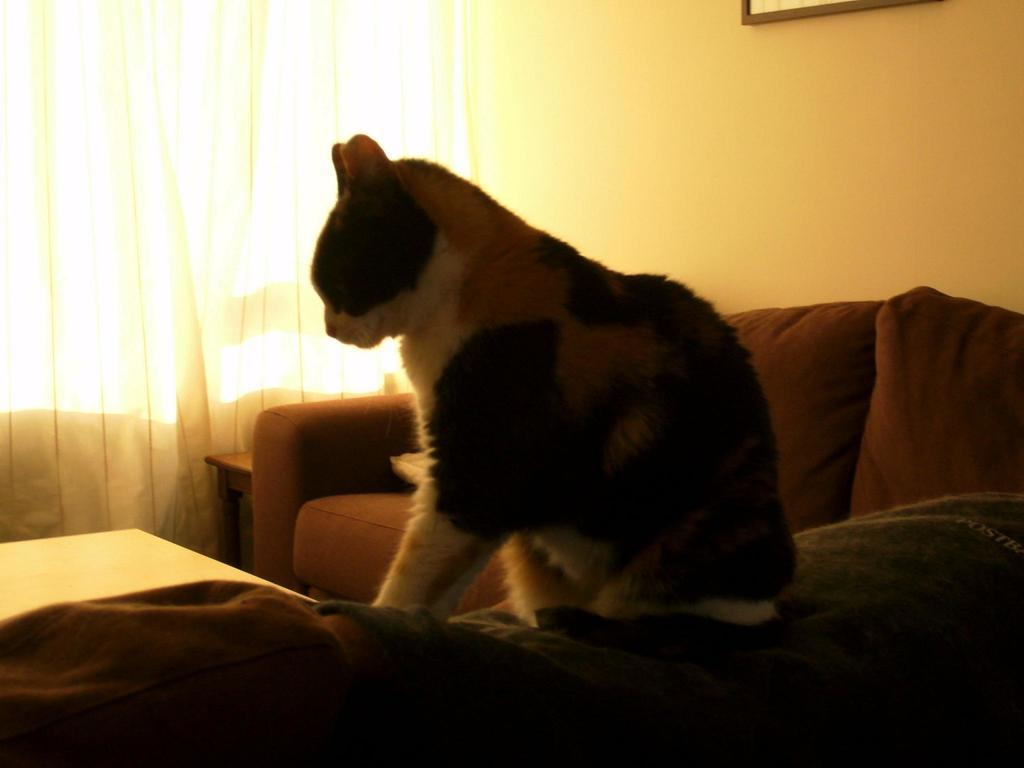What animal can be seen in the image? There is a cat in the image. Where is the cat located? The cat is sitting on a sofa. What is hanging on the wall in the image? There is a curtain on the wall. What piece of furniture is in front of the curtain? There is a table in front of the curtain. What historical event is depicted in the image? There is no historical event depicted in the image; it features a cat sitting on a sofa with a curtain and table nearby. 